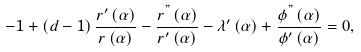Convert formula to latex. <formula><loc_0><loc_0><loc_500><loc_500>- 1 + \left ( d - 1 \right ) \frac { r ^ { \prime } \left ( \alpha \right ) } { r \left ( \alpha \right ) } - \frac { r ^ { " } \left ( \alpha \right ) } { r ^ { \prime } \left ( \alpha \right ) } - \lambda ^ { \prime } \left ( \alpha \right ) + \frac { \phi ^ { " } \left ( \alpha \right ) } { \phi ^ { \prime } \left ( \alpha \right ) } = 0 ,</formula> 